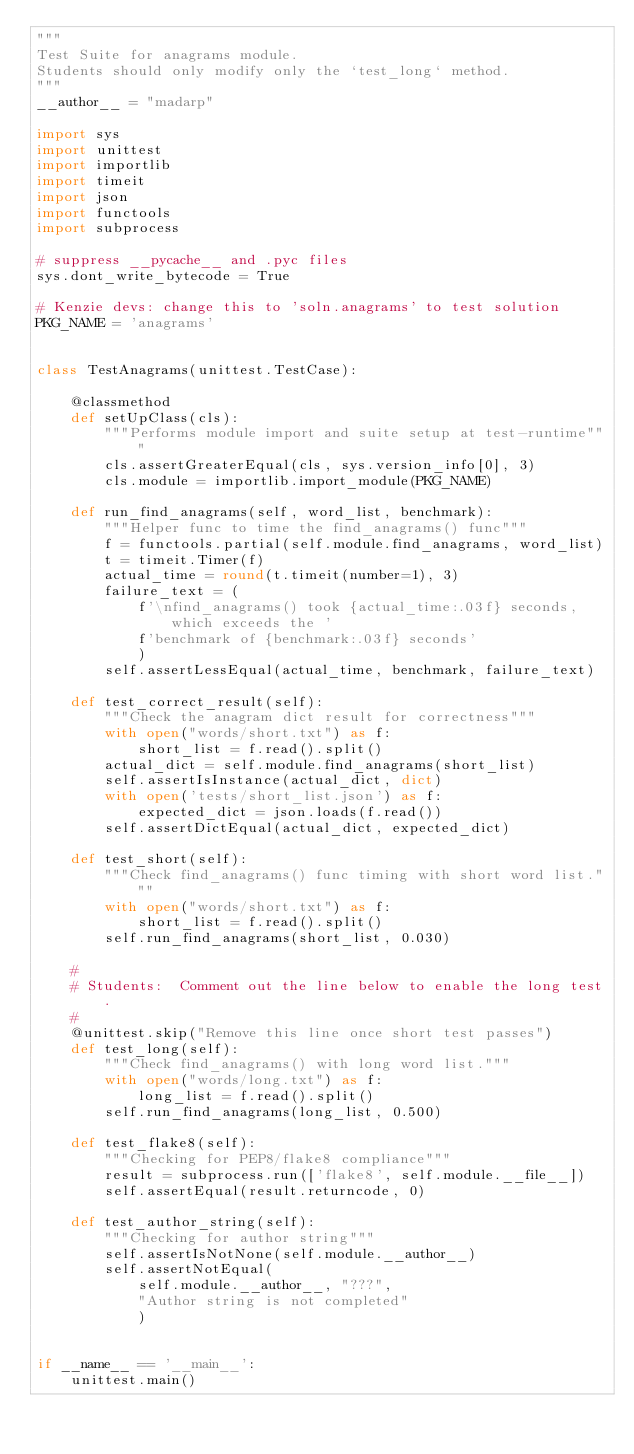Convert code to text. <code><loc_0><loc_0><loc_500><loc_500><_Python_>"""
Test Suite for anagrams module. 
Students should only modify only the `test_long` method.
"""
__author__ = "madarp"

import sys
import unittest
import importlib
import timeit
import json
import functools
import subprocess

# suppress __pycache__ and .pyc files
sys.dont_write_bytecode = True

# Kenzie devs: change this to 'soln.anagrams' to test solution
PKG_NAME = 'anagrams'


class TestAnagrams(unittest.TestCase):

    @classmethod
    def setUpClass(cls):
        """Performs module import and suite setup at test-runtime"""
        cls.assertGreaterEqual(cls, sys.version_info[0], 3)
        cls.module = importlib.import_module(PKG_NAME)

    def run_find_anagrams(self, word_list, benchmark):
        """Helper func to time the find_anagrams() func"""
        f = functools.partial(self.module.find_anagrams, word_list)
        t = timeit.Timer(f)
        actual_time = round(t.timeit(number=1), 3)
        failure_text = (
            f'\nfind_anagrams() took {actual_time:.03f} seconds, which exceeds the '
            f'benchmark of {benchmark:.03f} seconds'
            )
        self.assertLessEqual(actual_time, benchmark, failure_text)

    def test_correct_result(self):
        """Check the anagram dict result for correctness"""
        with open("words/short.txt") as f:
            short_list = f.read().split()
        actual_dict = self.module.find_anagrams(short_list)
        self.assertIsInstance(actual_dict, dict)
        with open('tests/short_list.json') as f:
            expected_dict = json.loads(f.read())
        self.assertDictEqual(actual_dict, expected_dict)

    def test_short(self):
        """Check find_anagrams() func timing with short word list."""
        with open("words/short.txt") as f:
            short_list = f.read().split()
        self.run_find_anagrams(short_list, 0.030)

    #
    # Students:  Comment out the line below to enable the long test.
    #
    @unittest.skip("Remove this line once short test passes")
    def test_long(self):
        """Check find_anagrams() with long word list."""
        with open("words/long.txt") as f:
            long_list = f.read().split()
        self.run_find_anagrams(long_list, 0.500)

    def test_flake8(self):
        """Checking for PEP8/flake8 compliance"""
        result = subprocess.run(['flake8', self.module.__file__])
        self.assertEqual(result.returncode, 0)

    def test_author_string(self):
        """Checking for author string"""
        self.assertIsNotNone(self.module.__author__)
        self.assertNotEqual(
            self.module.__author__, "???",
            "Author string is not completed"
            )


if __name__ == '__main__':
    unittest.main()
</code> 